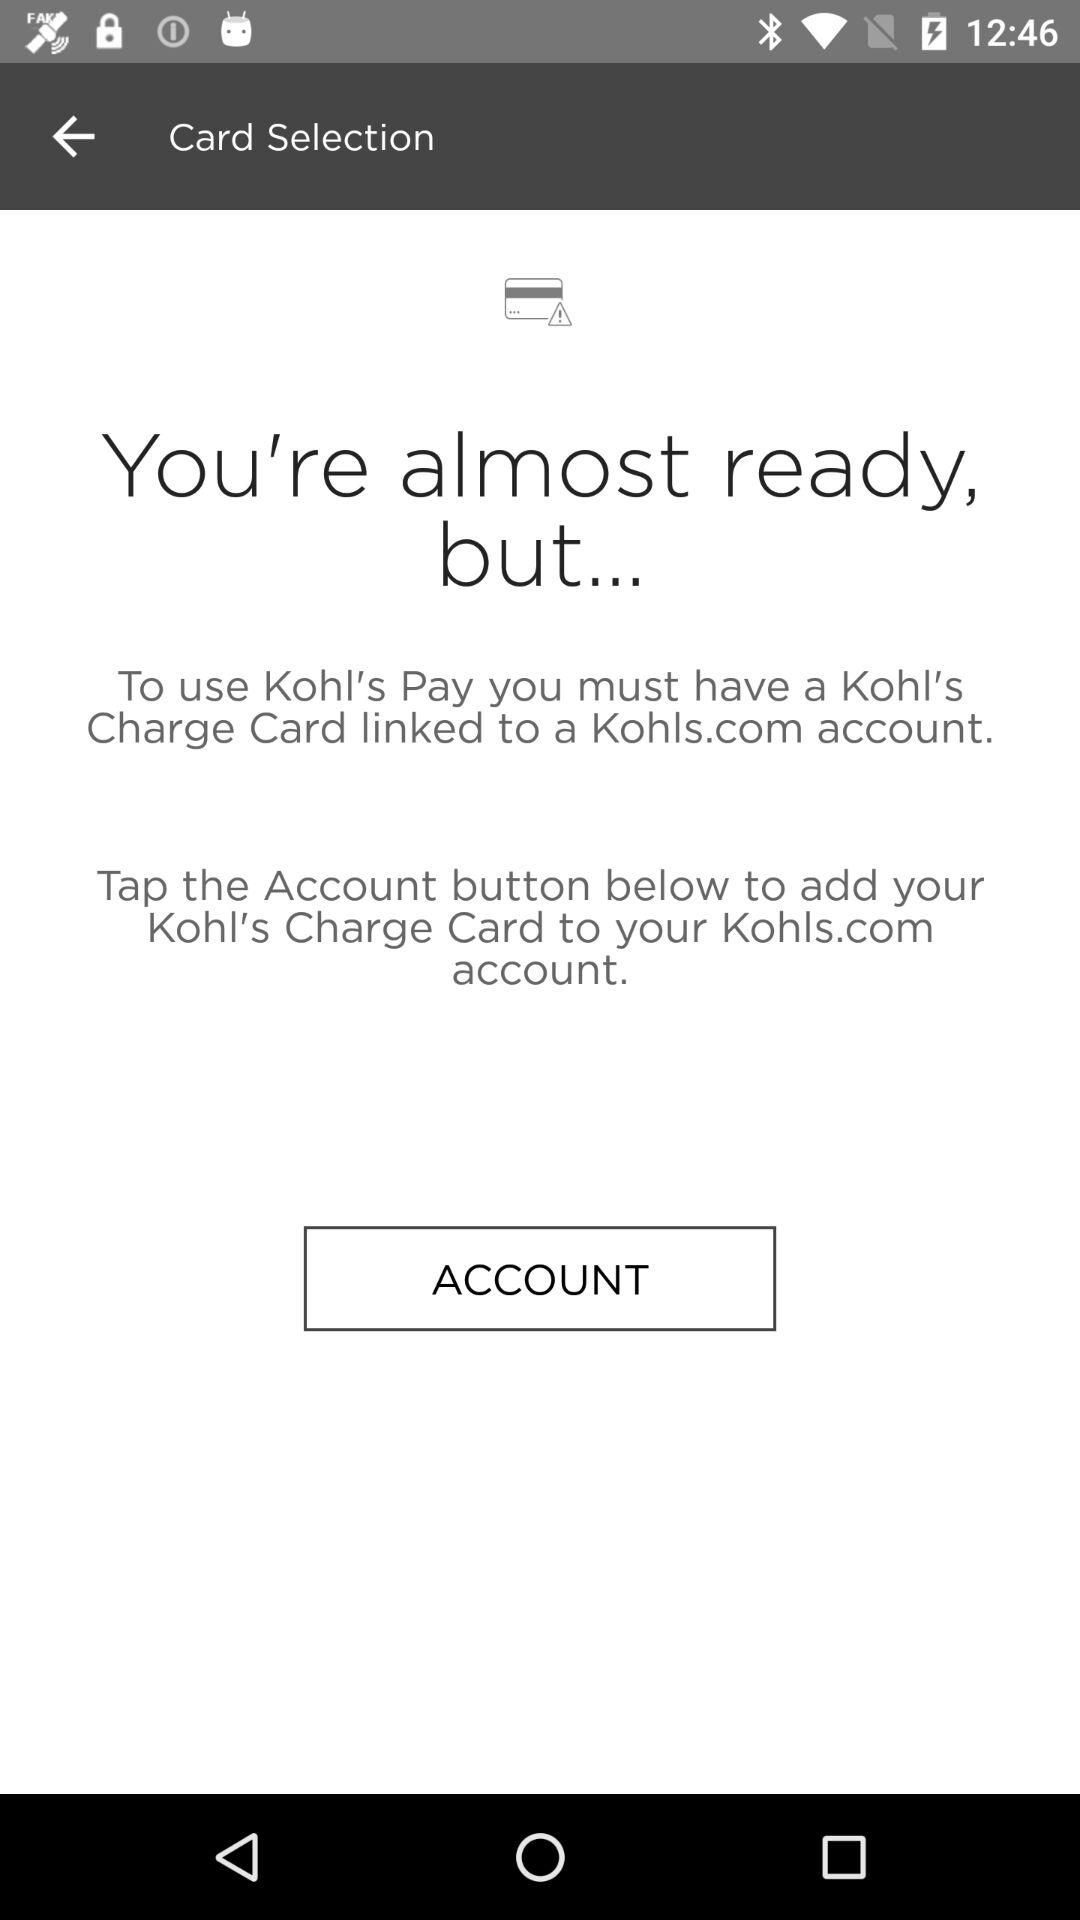How can the user use Kohl's Pay? The user can use Kohl's Pay by having a Kohl's charge card linked to the Kohls.com account. 